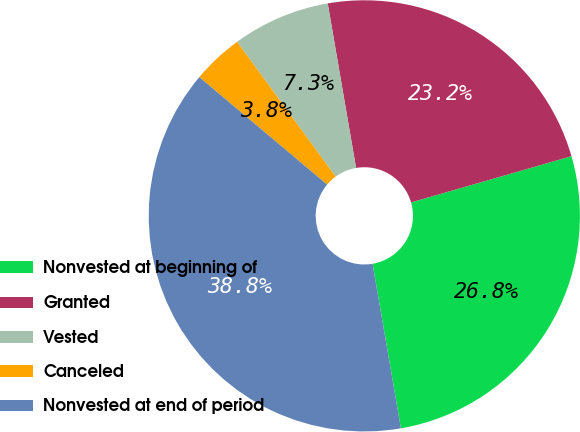Convert chart. <chart><loc_0><loc_0><loc_500><loc_500><pie_chart><fcel>Nonvested at beginning of<fcel>Granted<fcel>Vested<fcel>Canceled<fcel>Nonvested at end of period<nl><fcel>26.75%<fcel>23.25%<fcel>7.33%<fcel>3.83%<fcel>38.84%<nl></chart> 